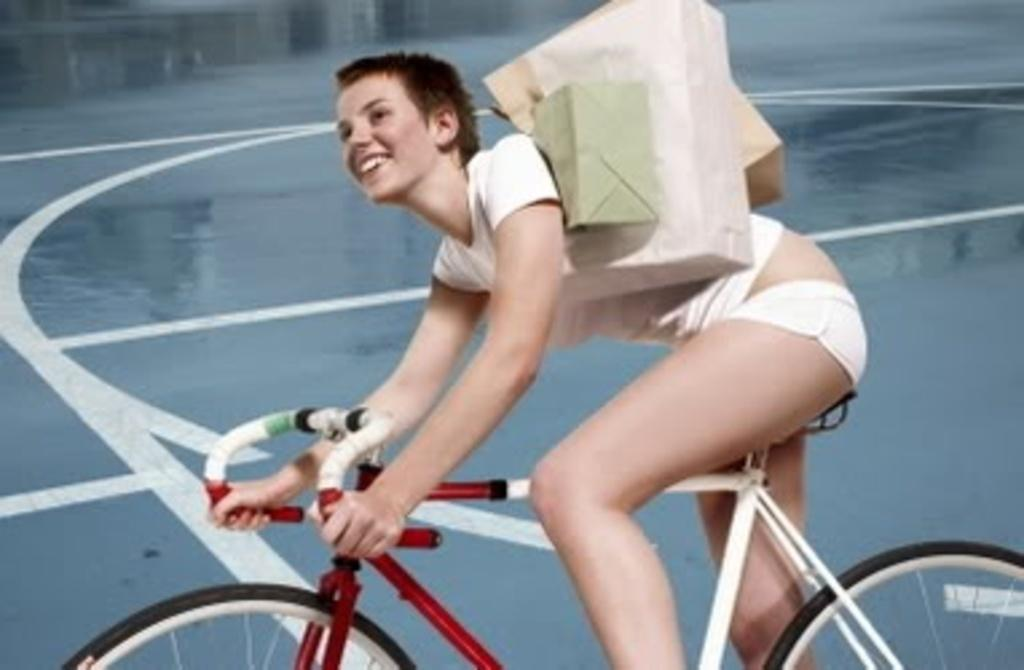What is the woman doing in the image? The woman is sitting in the image. What is the woman holding in the image? The woman is holding a bicycle and bags. What is the color of the background in the image? The background color is blue. How many horses can be seen in the image? There are no horses present in the image. What type of sense is the woman using to interact with the bicycle? The provided facts do not mention any specific sense being used by the woman in the image. 